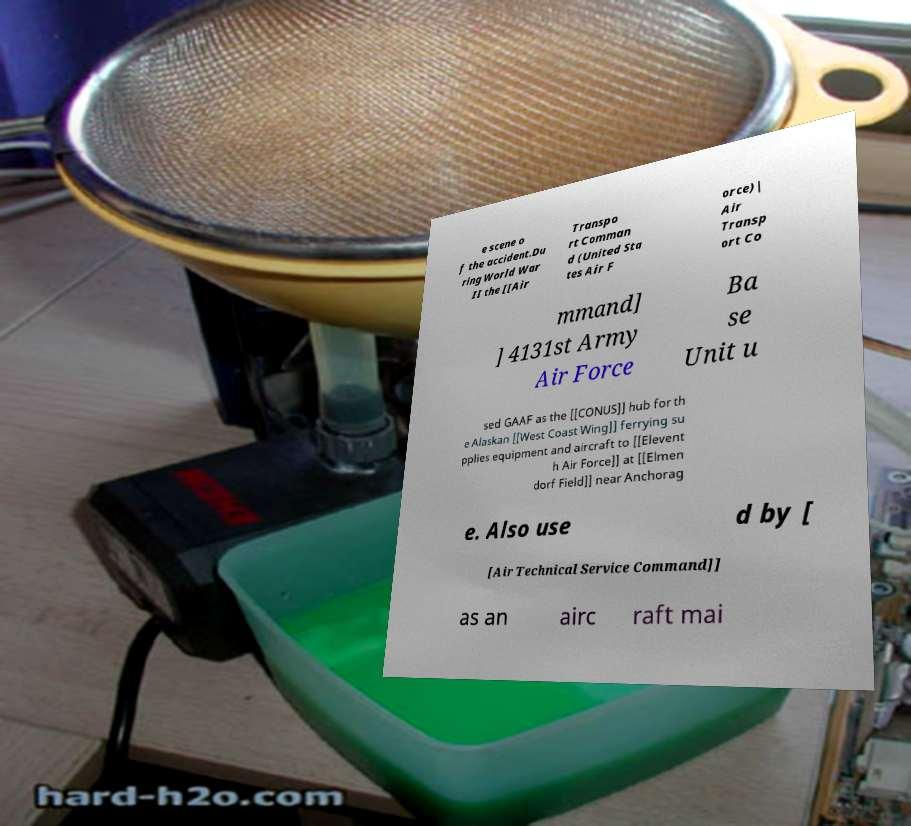Please read and relay the text visible in this image. What does it say? e scene o f the accident.Du ring World War II the [[Air Transpo rt Comman d (United Sta tes Air F orce)| Air Transp ort Co mmand] ] 4131st Army Air Force Ba se Unit u sed GAAF as the [[CONUS]] hub for th e Alaskan [[West Coast Wing]] ferrying su pplies equipment and aircraft to [[Elevent h Air Force]] at [[Elmen dorf Field]] near Anchorag e. Also use d by [ [Air Technical Service Command]] as an airc raft mai 